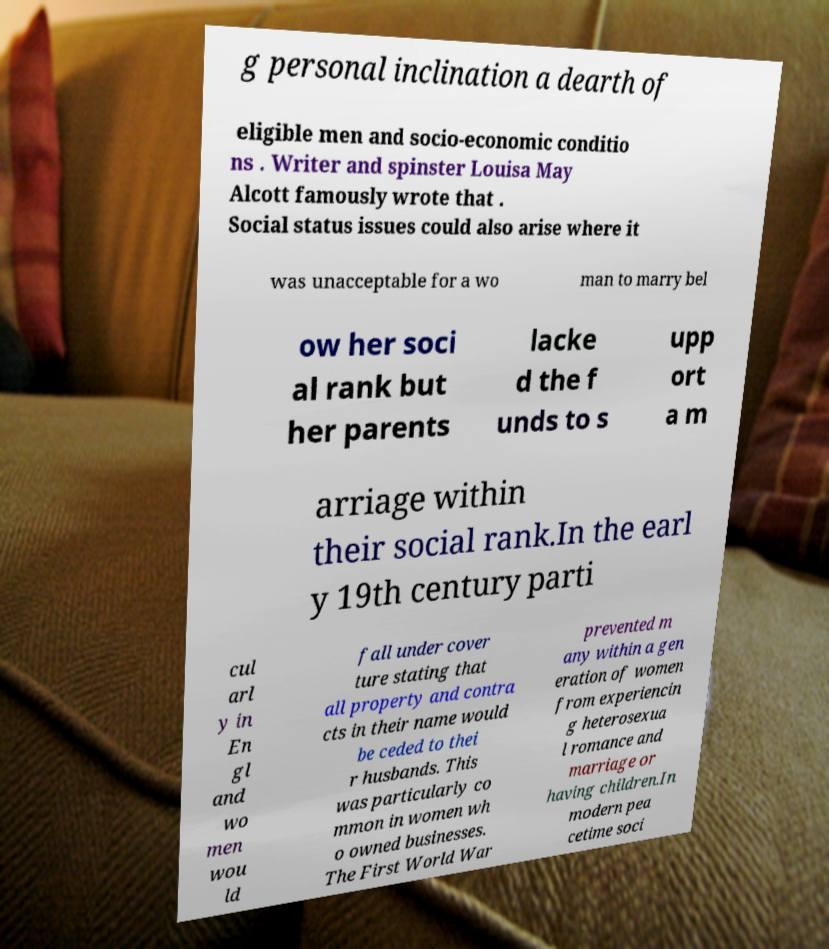Can you read and provide the text displayed in the image?This photo seems to have some interesting text. Can you extract and type it out for me? g personal inclination a dearth of eligible men and socio-economic conditio ns . Writer and spinster Louisa May Alcott famously wrote that . Social status issues could also arise where it was unacceptable for a wo man to marry bel ow her soci al rank but her parents lacke d the f unds to s upp ort a m arriage within their social rank.In the earl y 19th century parti cul arl y in En gl and wo men wou ld fall under cover ture stating that all property and contra cts in their name would be ceded to thei r husbands. This was particularly co mmon in women wh o owned businesses. The First World War prevented m any within a gen eration of women from experiencin g heterosexua l romance and marriage or having children.In modern pea cetime soci 